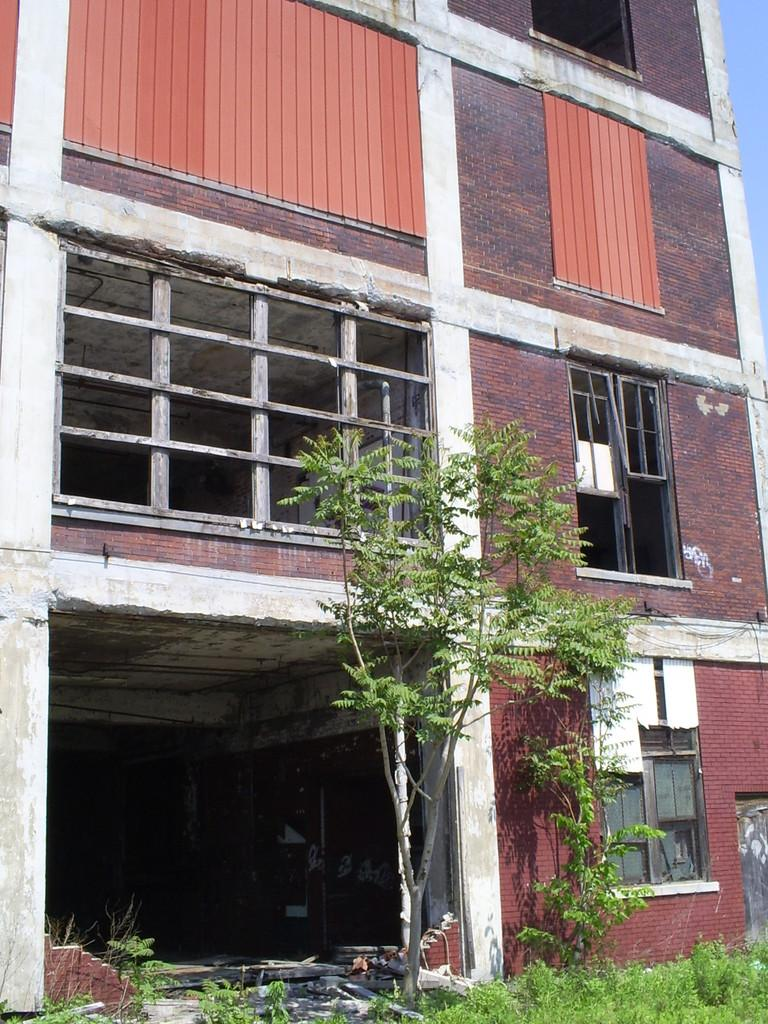What type of structure is visible in the image? There is a building in the image. What natural elements can be seen in the image? There are trees and plants in the image. What type of ground cover is present in the image? There is grass on the ground in the image. What type of fiction is being read by the key in the image? There is no key or fiction present in the image. 